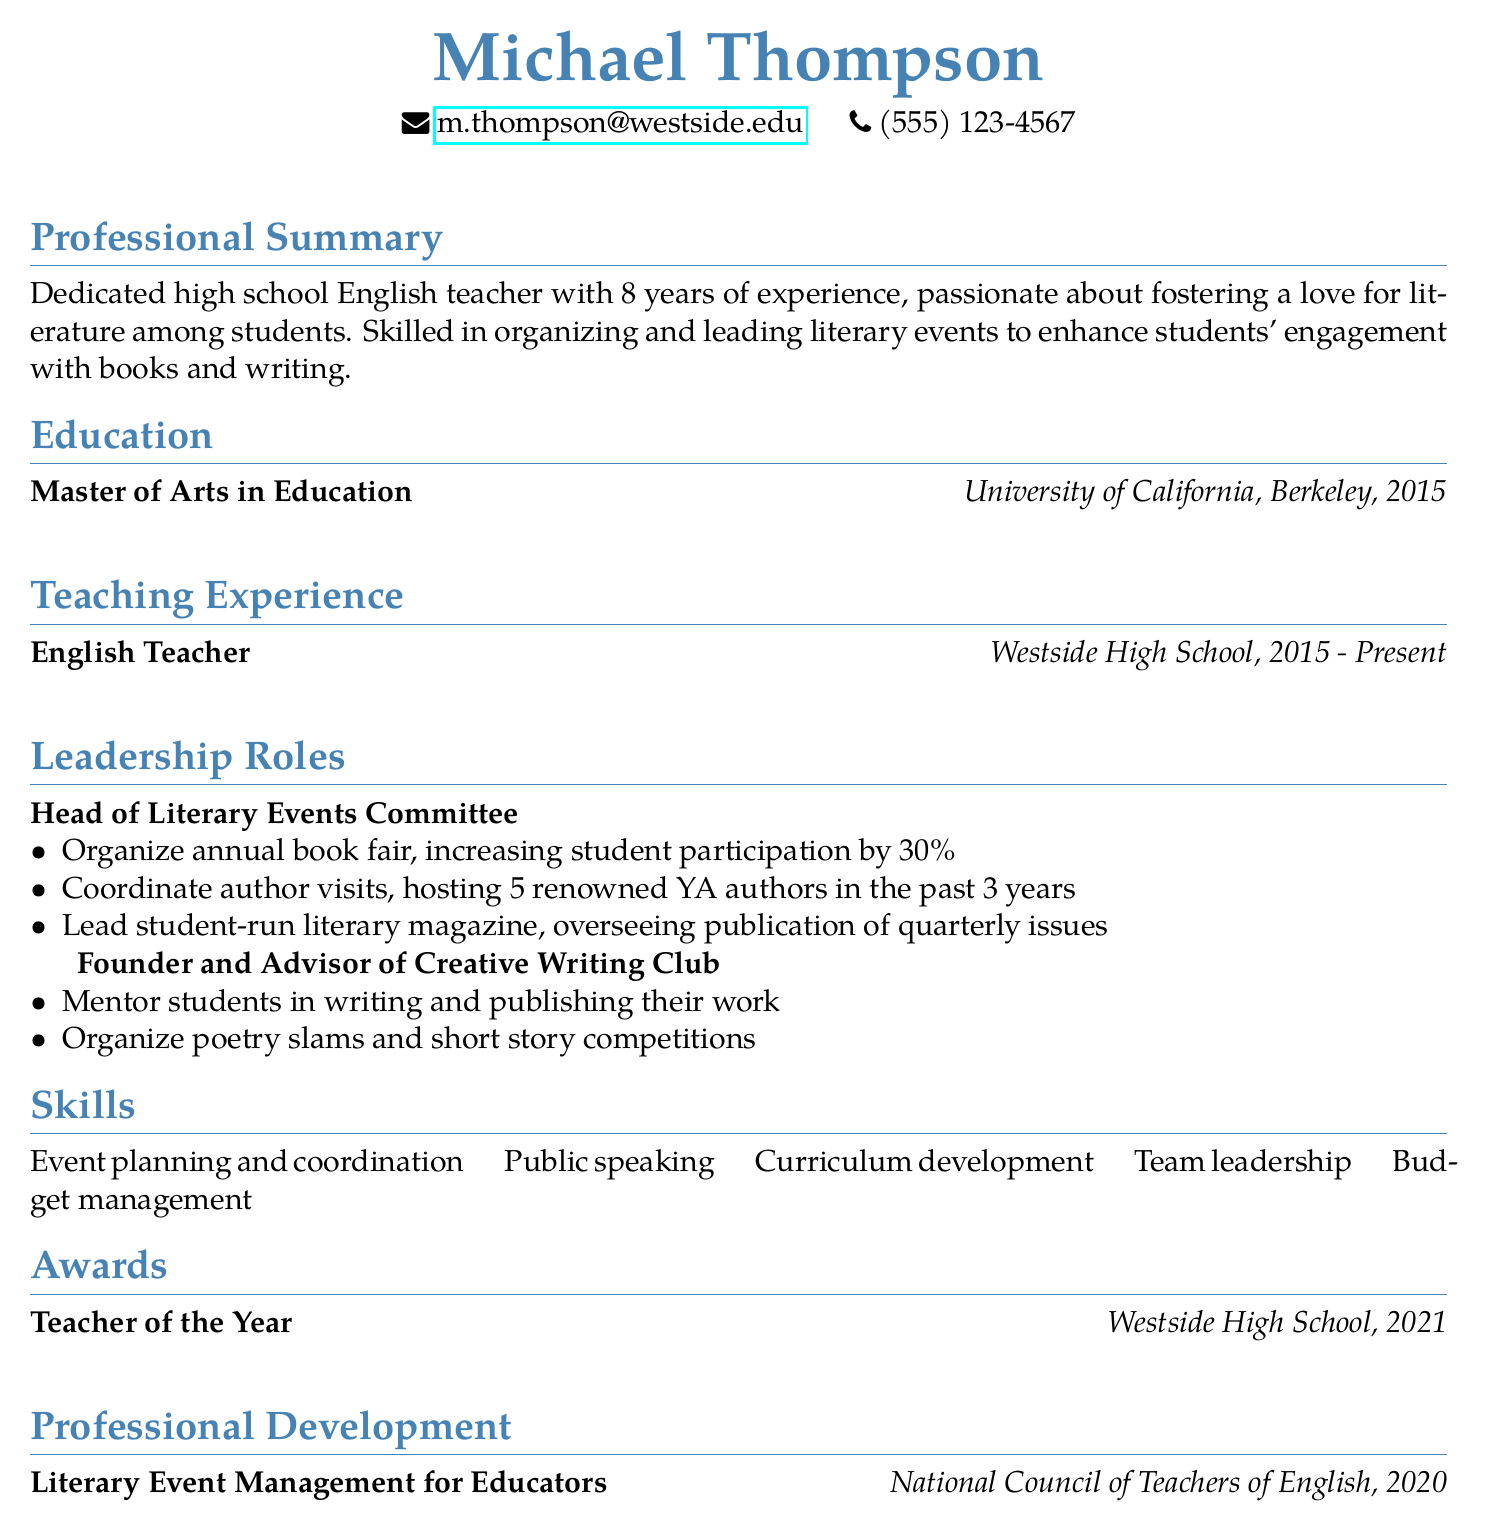what is the name of the individual? The name of the individual is listed at the beginning of the document.
Answer: Michael Thompson what is the email address provided? The email address is provided under personal information.
Answer: m.thompson@westside.edu how many years of teaching experience does the individual have? The number of years of experience is mentioned in the professional summary.
Answer: 8 years which degree was earned and from which institution? The degree and institution are found in the education section.
Answer: Master of Arts in Education, University of California, Berkeley what title is held by the individual in the Literary Events Committee? The title is mentioned in the leadership roles section.
Answer: Head of Literary Events Committee how many renowned authors were hosted in the past 3 years? This information is detailed in the responsibilities of the Literary Events Committee.
Answer: 5 renowned YA authors what award did the individual receive and in what year? The award title and year are listed in the awards section of the document.
Answer: Teacher of the Year, 2021 which organization did the individual receive professional development from? The institution is mentioned in the professional development section.
Answer: National Council of Teachers of English what skill is emphasized in the document related to managing events? Skills mentioned in the skills section include several specific attributes.
Answer: Event planning and coordination 